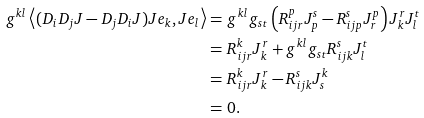<formula> <loc_0><loc_0><loc_500><loc_500>g ^ { k l } \left < ( D _ { i } D _ { j } J - D _ { j } D _ { i } J ) J e _ { k } , J e _ { l } \right > = & \ g ^ { k l } g _ { s t } \left ( R _ { i j r } ^ { p } J _ { p } ^ { s } - R _ { i j p } ^ { s } J _ { r } ^ { p } \right ) J _ { k } ^ { r } J _ { l } ^ { t } \\ = & \ R _ { i j r } ^ { k } J _ { k } ^ { r } + g ^ { k l } g _ { s t } R _ { i j k } ^ { s } J _ { l } ^ { t } \\ = & \ R _ { i j r } ^ { k } J _ { k } ^ { r } - R _ { i j k } ^ { s } J _ { s } ^ { k } \\ = & \ 0 .</formula> 